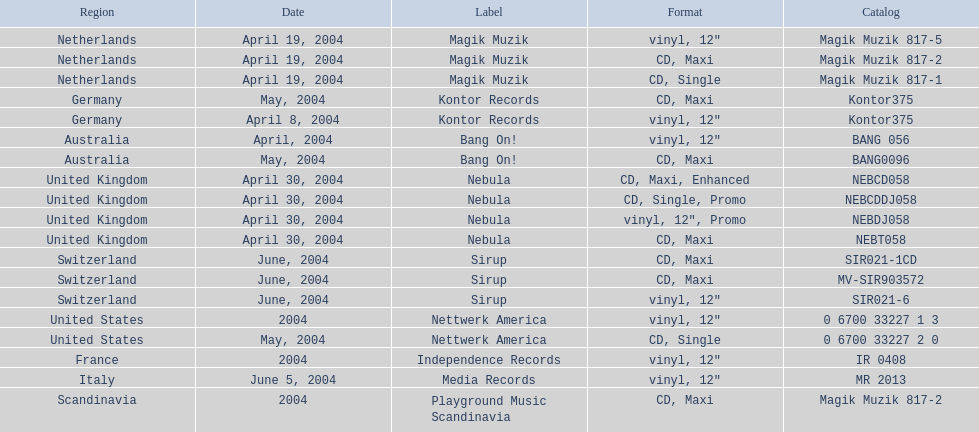I'm looking to parse the entire table for insights. Could you assist me with that? {'header': ['Region', 'Date', 'Label', 'Format', 'Catalog'], 'rows': [['Netherlands', 'April 19, 2004', 'Magik Muzik', 'vinyl, 12"', 'Magik Muzik 817-5'], ['Netherlands', 'April 19, 2004', 'Magik Muzik', 'CD, Maxi', 'Magik Muzik 817-2'], ['Netherlands', 'April 19, 2004', 'Magik Muzik', 'CD, Single', 'Magik Muzik 817-1'], ['Germany', 'May, 2004', 'Kontor Records', 'CD, Maxi', 'Kontor375'], ['Germany', 'April 8, 2004', 'Kontor Records', 'vinyl, 12"', 'Kontor375'], ['Australia', 'April, 2004', 'Bang On!', 'vinyl, 12"', 'BANG 056'], ['Australia', 'May, 2004', 'Bang On!', 'CD, Maxi', 'BANG0096'], ['United Kingdom', 'April 30, 2004', 'Nebula', 'CD, Maxi, Enhanced', 'NEBCD058'], ['United Kingdom', 'April 30, 2004', 'Nebula', 'CD, Single, Promo', 'NEBCDDJ058'], ['United Kingdom', 'April 30, 2004', 'Nebula', 'vinyl, 12", Promo', 'NEBDJ058'], ['United Kingdom', 'April 30, 2004', 'Nebula', 'CD, Maxi', 'NEBT058'], ['Switzerland', 'June, 2004', 'Sirup', 'CD, Maxi', 'SIR021-1CD'], ['Switzerland', 'June, 2004', 'Sirup', 'CD, Maxi', 'MV-SIR903572'], ['Switzerland', 'June, 2004', 'Sirup', 'vinyl, 12"', 'SIR021-6'], ['United States', '2004', 'Nettwerk America', 'vinyl, 12"', '0 6700 33227 1 3'], ['United States', 'May, 2004', 'Nettwerk America', 'CD, Single', '0 6700 33227 2 0'], ['France', '2004', 'Independence Records', 'vinyl, 12"', 'IR 0408'], ['Italy', 'June 5, 2004', 'Media Records', 'vinyl, 12"', 'MR 2013'], ['Scandinavia', '2004', 'Playground Music Scandinavia', 'CD, Maxi', 'Magik Muzik 817-2']]} What area was included in the sir021-1cd catalogue? Switzerland. 